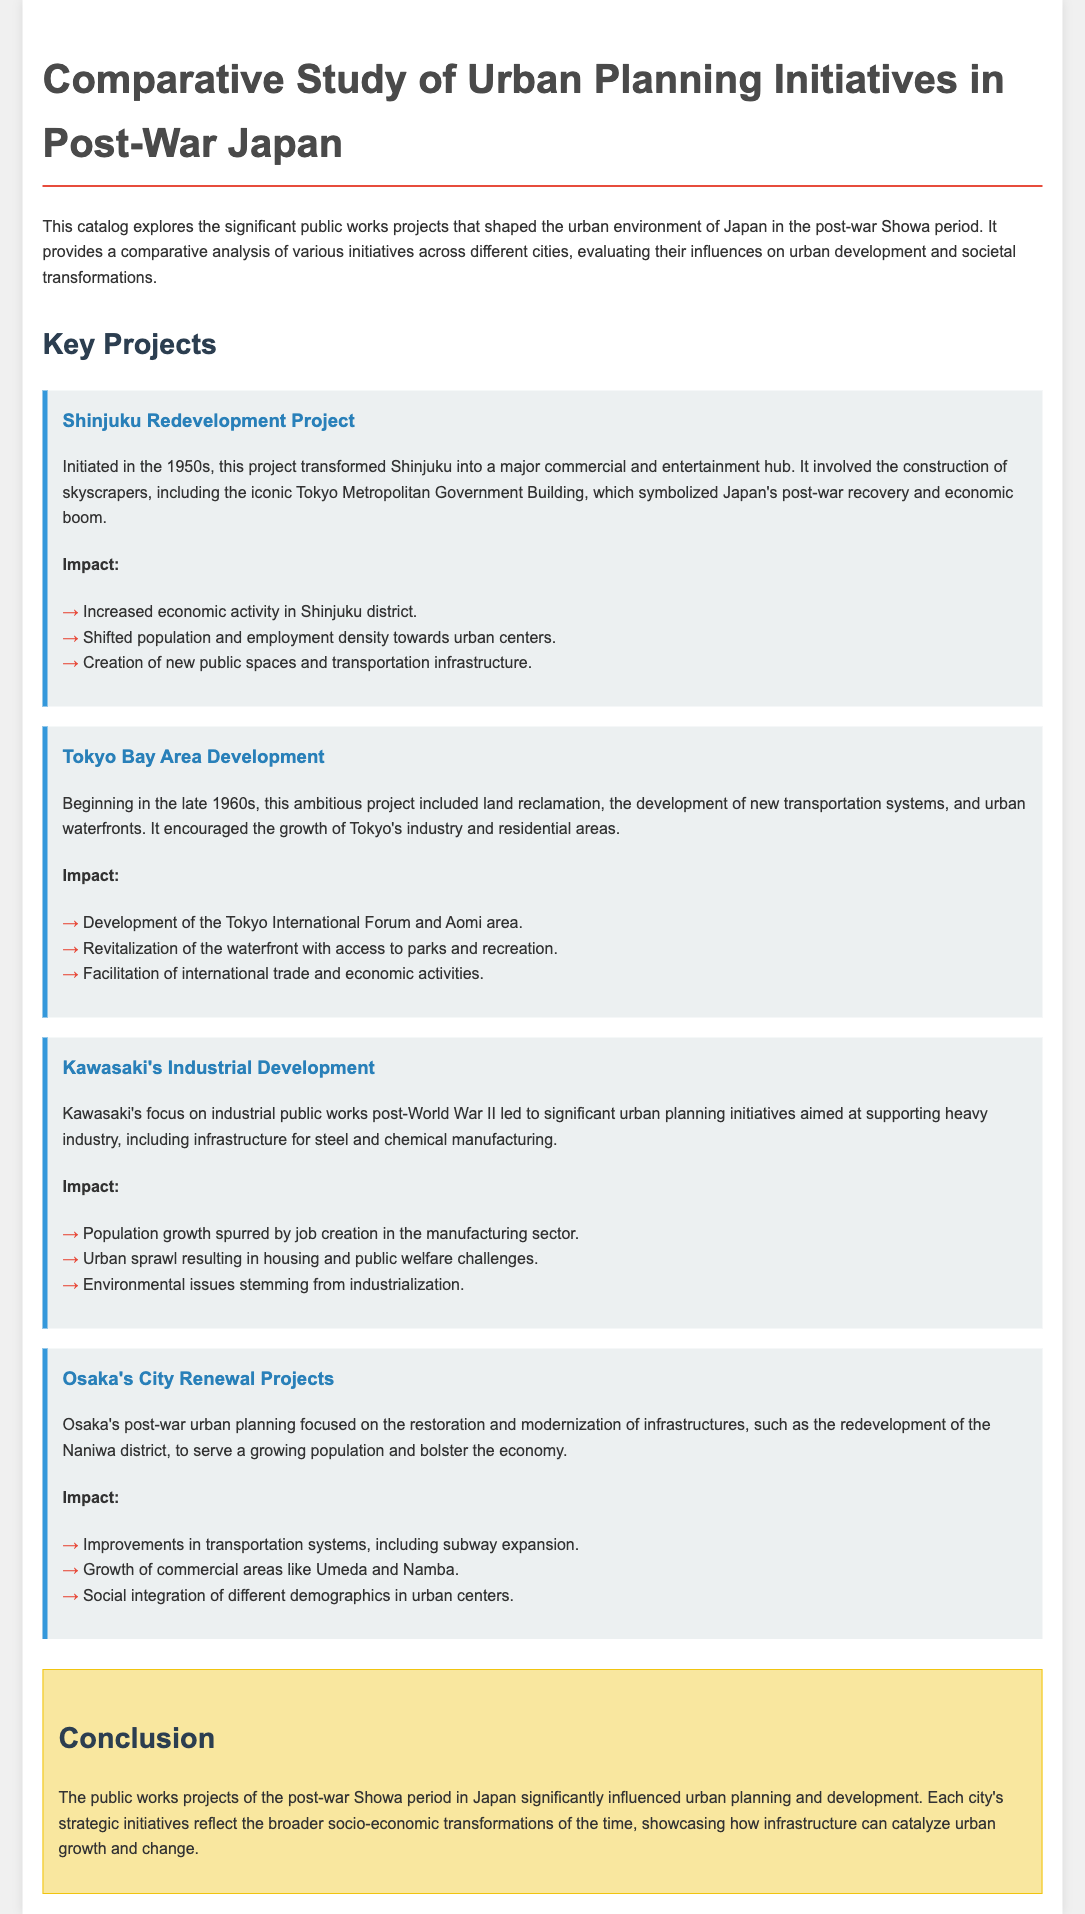What is the title of the catalog? The title of the catalog is prominently displayed at the top of the document, which is "Comparative Study of Urban Planning Initiatives in Post-War Japan."
Answer: Comparative Study of Urban Planning Initiatives in Post-War Japan When did the Shinjuku Redevelopment Project begin? The document mentions that the Shinjuku Redevelopment Project was initiated in the 1950s.
Answer: 1950s What significant development occurred in the Tokyo Bay Area? The Tokyo Bay Area Development is noted for significant changes including land reclamation and new transportation systems starting in the late 1960s.
Answer: Land reclamation Which district in Osaka underwent modernization? The document refers to the Naniwa district as the area that was restored and modernized as part of Osaka's post-war urban planning.
Answer: Naniwa What were the social impacts of Kawasaki's industrial development? The document outlines population growth spurred by job creation and urban sprawl leading to challenges, specifically noting environmental issues as a consequence.
Answer: Environmental issues Which infrastructure improvement is highlighted in Osaka's City Renewal Projects? An important improvement highlighted in the text is the expansion of transportation systems, specifically the subway.
Answer: Subway expansion What was a major impact of the Shinjuku Redevelopment Project? The document lists several impacts of this project, one major impact being the increased economic activity in the Shinjuku district.
Answer: Increased economic activity What is the overall conclusion of the catalog? The conclusion summarizes the significant influence of public works projects on urban planning during the Showa period, reflecting broader socio-economic transformations.
Answer: Infrastructure can catalyze urban growth and change 